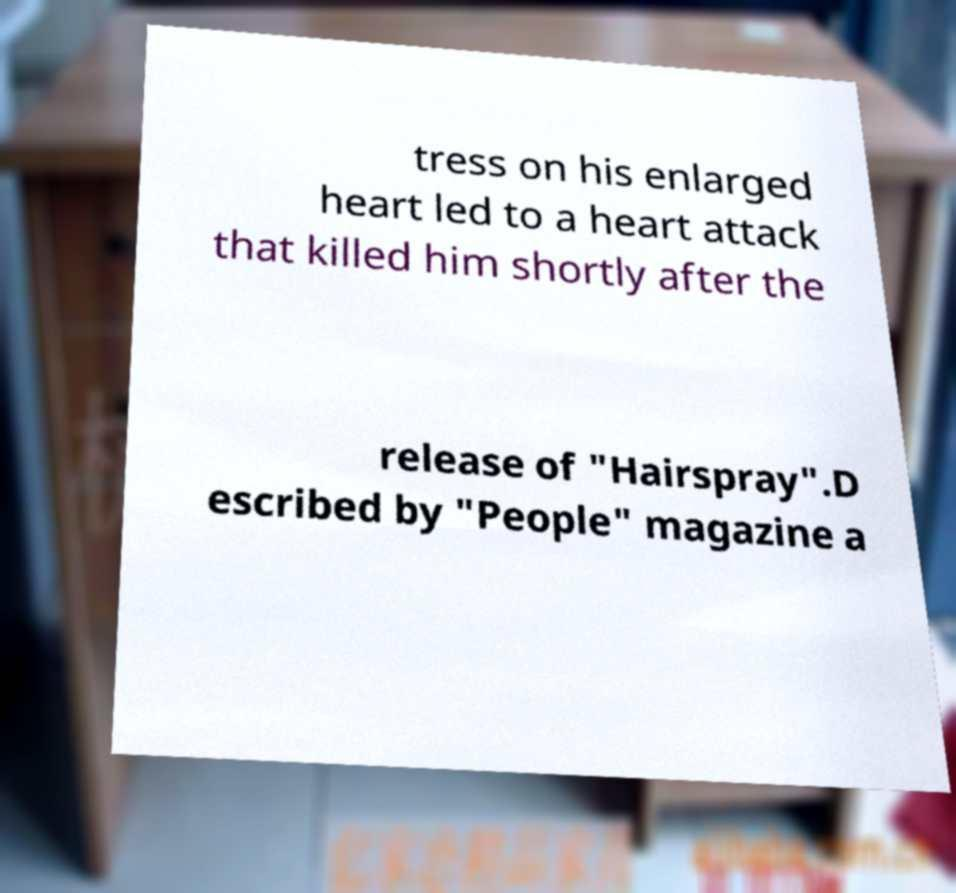I need the written content from this picture converted into text. Can you do that? tress on his enlarged heart led to a heart attack that killed him shortly after the release of "Hairspray".D escribed by "People" magazine a 